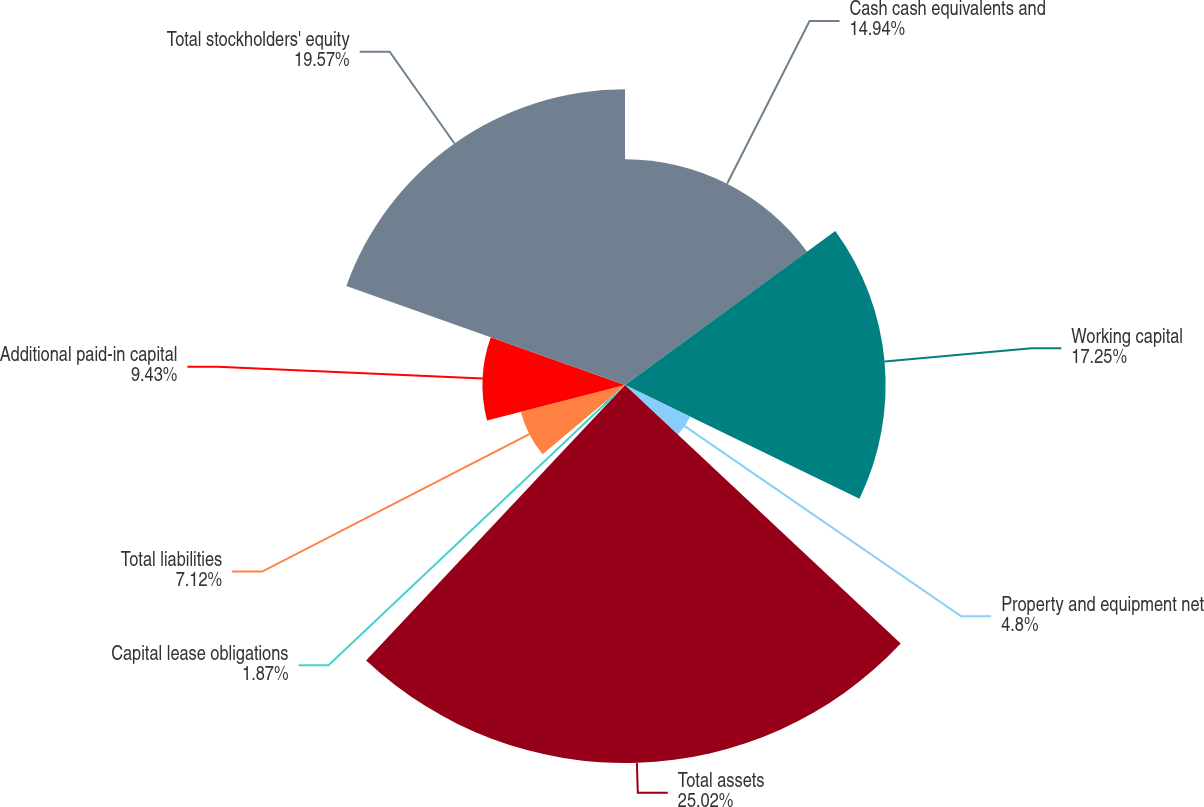Convert chart. <chart><loc_0><loc_0><loc_500><loc_500><pie_chart><fcel>Cash cash equivalents and<fcel>Working capital<fcel>Property and equipment net<fcel>Total assets<fcel>Capital lease obligations<fcel>Total liabilities<fcel>Additional paid-in capital<fcel>Total stockholders' equity<nl><fcel>14.94%<fcel>17.25%<fcel>4.8%<fcel>25.02%<fcel>1.87%<fcel>7.12%<fcel>9.43%<fcel>19.57%<nl></chart> 